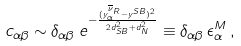Convert formula to latex. <formula><loc_0><loc_0><loc_500><loc_500>c _ { \alpha \beta } \sim \delta _ { \alpha \beta } \, e ^ { - \frac { ( y ^ { \overline { \nu } _ { R } } _ { \alpha } - y ^ { S B } ) ^ { 2 } } { 2 d _ { S B } ^ { 2 } + d _ { N } ^ { 2 } } } \equiv \delta _ { \alpha \beta } \, \epsilon _ { \alpha } ^ { M } \, ,</formula> 